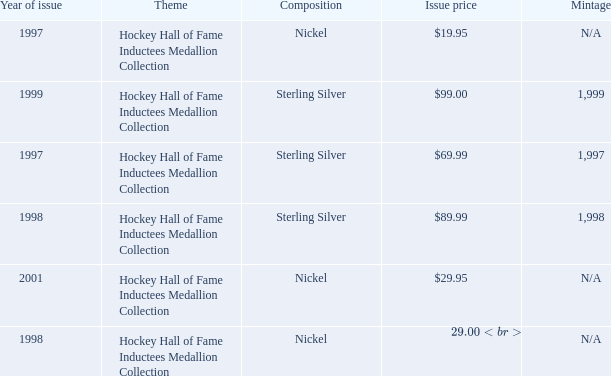Which composition has an issue price of $99.00? Sterling Silver. 